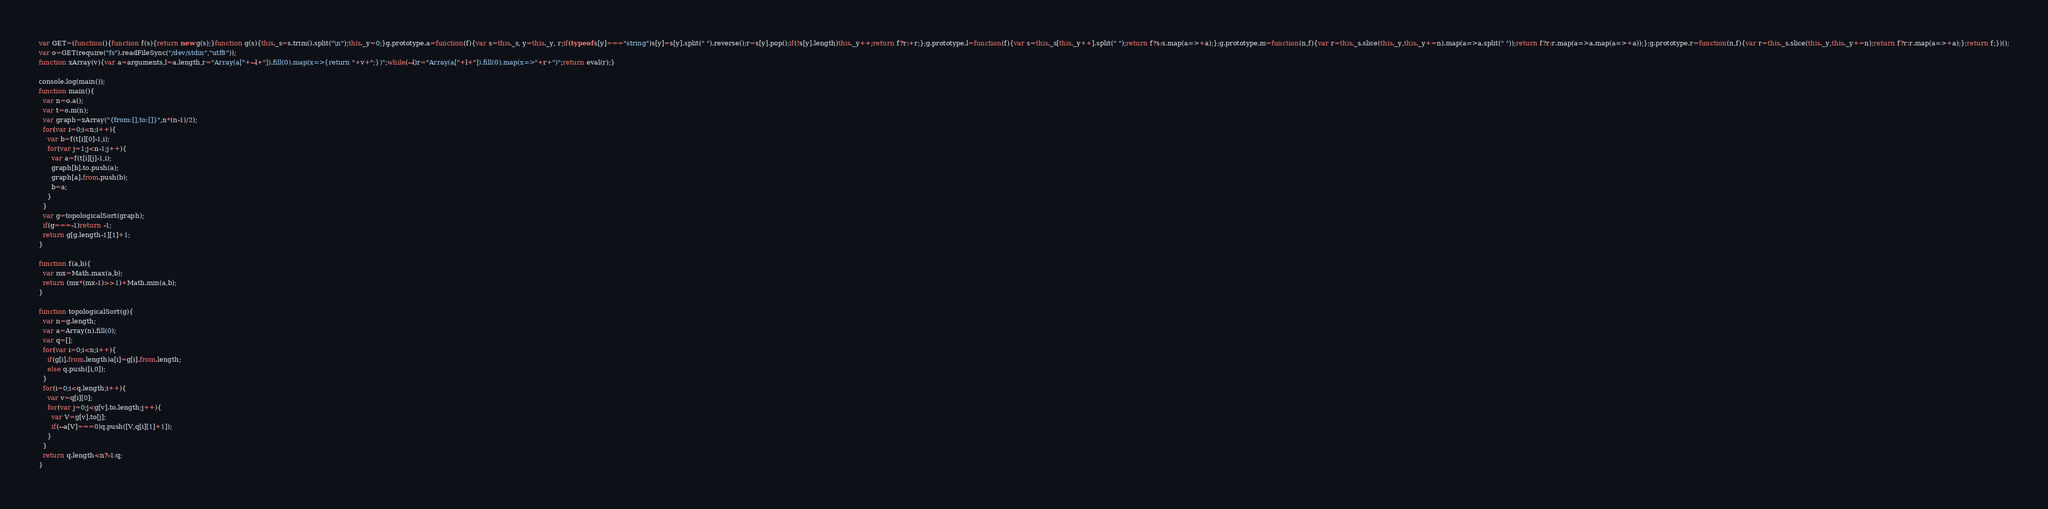Convert code to text. <code><loc_0><loc_0><loc_500><loc_500><_JavaScript_>var GET=(function(){function f(s){return new g(s);}function g(s){this._s=s.trim().split("\n");this._y=0;}g.prototype.a=function(f){var s=this._s, y=this._y, r;if(typeof s[y]==="string")s[y]=s[y].split(" ").reverse();r=s[y].pop();if(!s[y].length)this._y++;return f?r:+r;};g.prototype.l=function(f){var s=this._s[this._y++].split(" ");return f?s:s.map(a=>+a);};g.prototype.m=function(n,f){var r=this._s.slice(this._y,this._y+=n).map(a=>a.split(" "));return f?r:r.map(a=>a.map(a=>+a));};g.prototype.r=function(n,f){var r=this._s.slice(this._y,this._y+=n);return f?r:r.map(a=>+a);};return f;})();
var o=GET(require("fs").readFileSync("/dev/stdin","utf8"));
function xArray(v){var a=arguments,l=a.length,r="Array(a["+--l+"]).fill(0).map(x=>{return "+v+";})";while(--l)r="Array(a["+l+"]).fill(0).map(x=>"+r+")";return eval(r);}

console.log(main());
function main(){
  var n=o.a();
  var t=o.m(n);
  var graph=xArray("{from:[],to:[]}",n*(n-1)/2);
  for(var i=0;i<n;i++){
    var b=f(t[i][0]-1,i);
    for(var j=1;j<n-1;j++){
      var a=f(t[i][j]-1,i);
      graph[b].to.push(a);
      graph[a].from.push(b);
      b=a;
    }
  }
  var g=topologicalSort(graph);
  if(g===-1)return -1;
  return g[g.length-1][1]+1;
}

function f(a,b){
  var mx=Math.max(a,b);
  return (mx*(mx-1)>>1)+Math.min(a,b);
}

function topologicalSort(g){
  var n=g.length;
  var a=Array(n).fill(0);
  var q=[];
  for(var i=0;i<n;i++){
    if(g[i].from.length)a[i]=g[i].from.length;
    else q.push([i,0]);
  }
  for(i=0;i<q.length;i++){
    var v=q[i][0];
    for(var j=0;j<g[v].to.length;j++){
      var V=g[v].to[j];
      if(--a[V]===0)q.push([V,q[i][1]+1]);
    }
  }
  return q.length<n?-1:q;
}</code> 